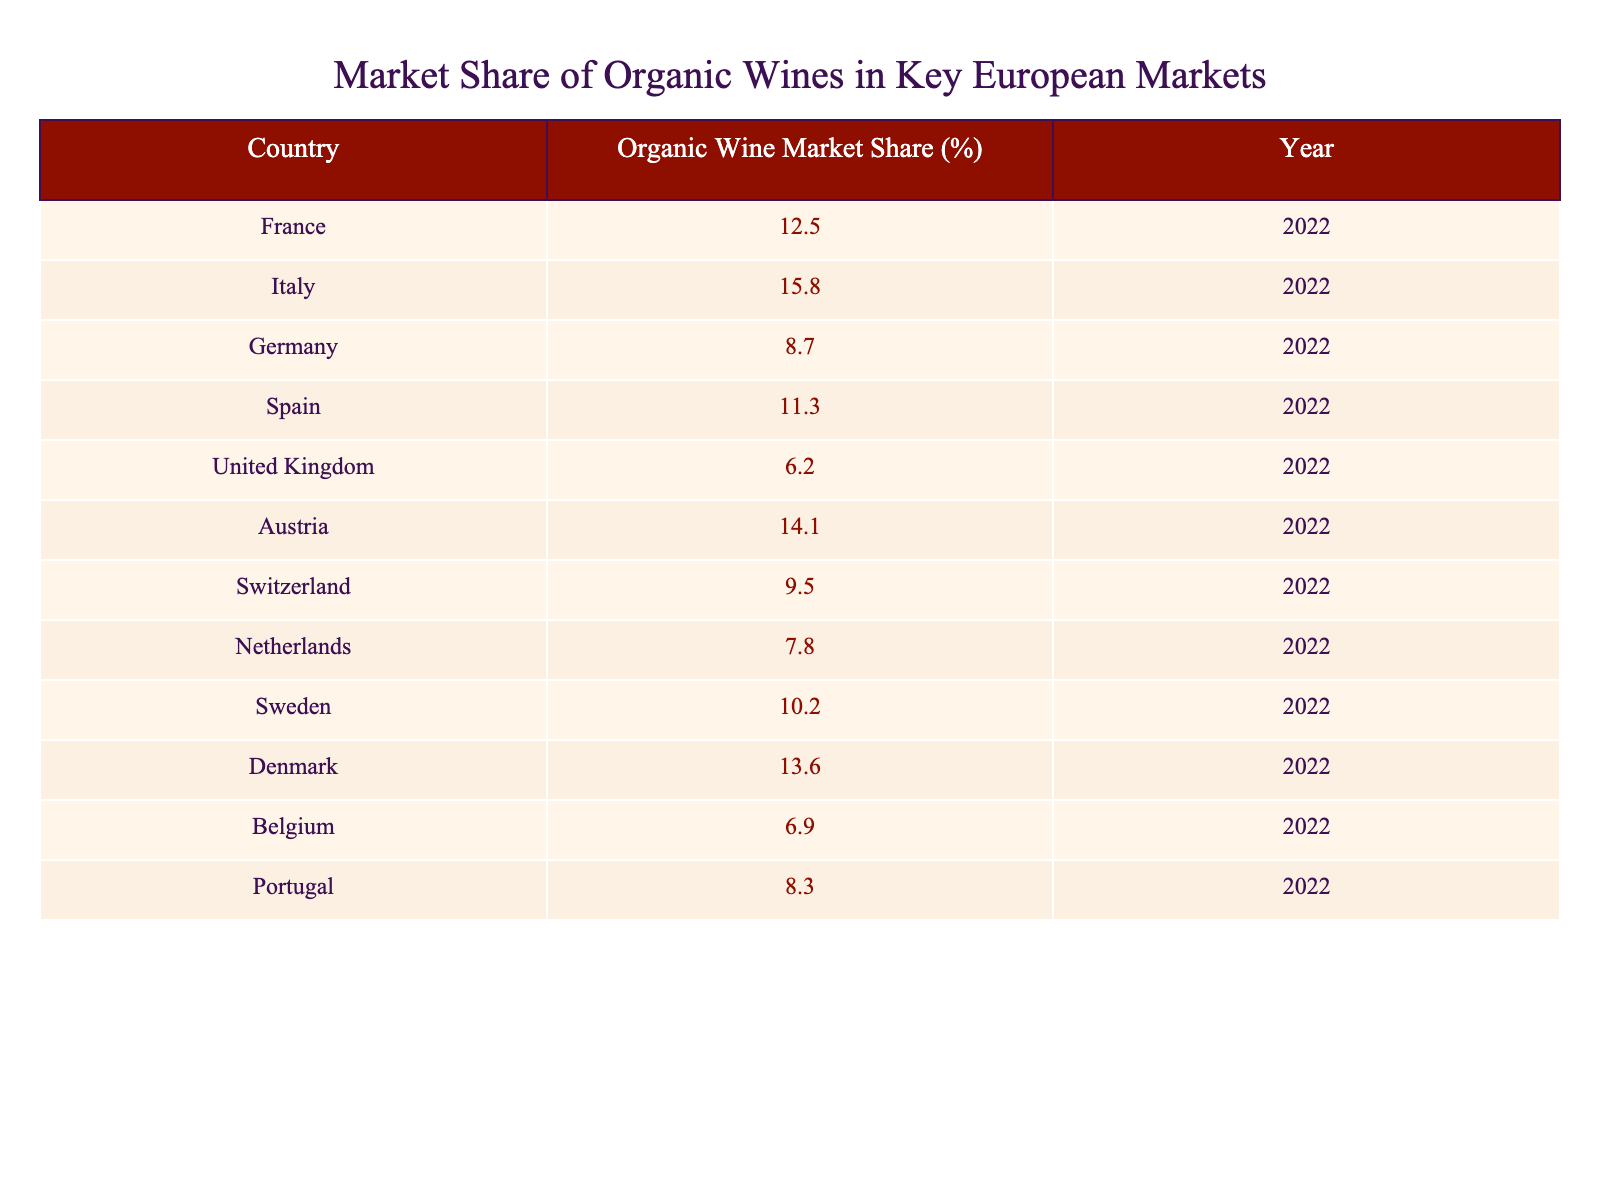What is the organic wine market share in Italy? The table lists Italy with an organic wine market share of 15.8%.
Answer: 15.8% Which country has the highest organic wine market share? By checking the values in the table, Italy has the highest market share at 15.8%.
Answer: Italy What is the combined organic wine market share of France and Spain? France has 12.5% and Spain has 11.3%. Adding them gives 12.5 + 11.3 = 23.8%.
Answer: 23.8% Is the organic wine market share in the United Kingdom higher than in Belgium? The UK has 6.2% and Belgium has 6.9%; therefore, the UK’s market share is not higher.
Answer: No What is the median organic wine market share among the listed countries? To find the median, we first list the market shares in ascending order: 6.2, 6.9, 7.8, 8.3, 8.7, 10.2, 11.3, 12.5, 13.6, 14.1, 15.8. There are 11 values, so the median is the 6th, which is 10.2%.
Answer: 10.2% Which countries have an organic wine market share above 10%? By reviewing the table, the countries above 10% are Italy (15.8%), Austria (14.1%), Denmark (13.6%), France (12.5%), and Spain (11.3%).
Answer: Italy, Austria, Denmark, France, Spain If the total market share of all countries is 100%, what percentage of this share is accounted for by the Netherlands and Sweden combined? The Netherlands has 7.8% and Sweden has 10.2%. Adding these gives 7.8 + 10.2 = 18%.
Answer: 18% What is the percentage difference in organic wine market share between Austria and Germany? Austria has 14.1% and Germany has 8.7%. The difference is 14.1 - 8.7 = 5.4%.
Answer: 5.4% 